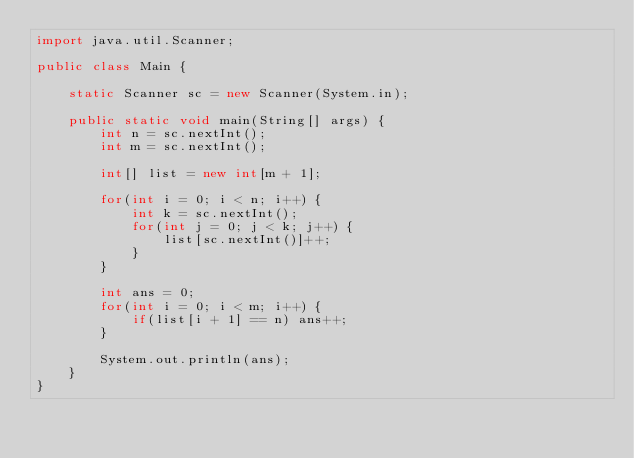Convert code to text. <code><loc_0><loc_0><loc_500><loc_500><_Java_>import java.util.Scanner;

public class Main {

	static Scanner sc = new Scanner(System.in);

	public static void main(String[] args) {
		int n = sc.nextInt();
		int m = sc.nextInt();

		int[] list = new int[m + 1];

		for(int i = 0; i < n; i++) {
			int k = sc.nextInt();
			for(int j = 0; j < k; j++) {
				list[sc.nextInt()]++;
			}
		}

		int ans = 0;
		for(int i = 0; i < m; i++) {
			if(list[i + 1] == n) ans++;
		}

		System.out.println(ans);
	}
}
</code> 